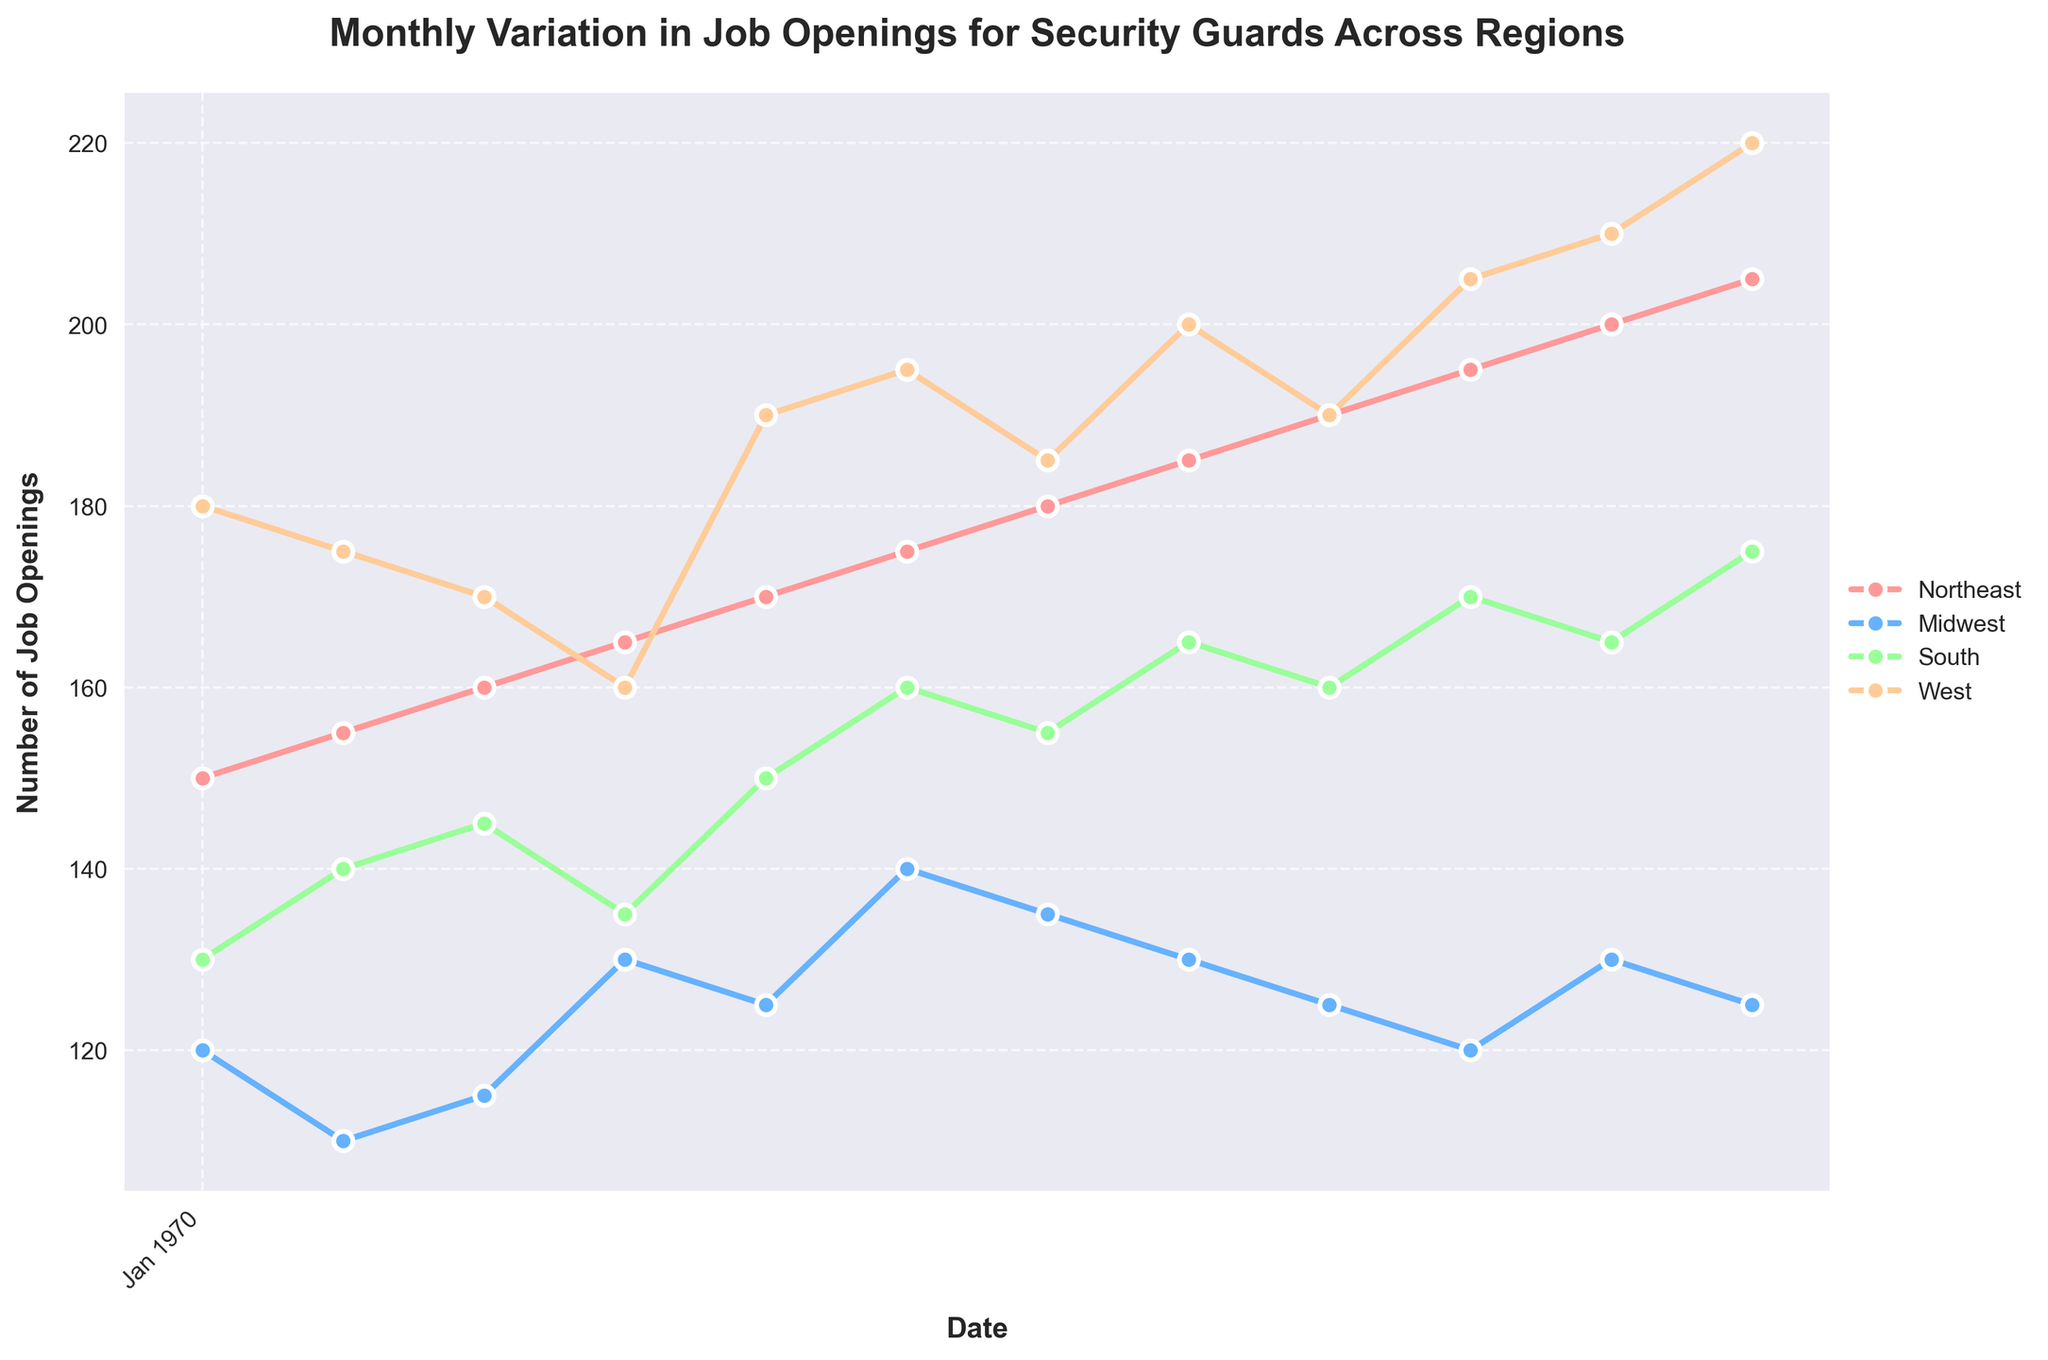What is the title of the figure? The title of the figure is usually placed at the top and is written in bold. In this case, the title is found in the center above the plot.
Answer: Monthly Variation in Job Openings for Security Guards Across Regions What are the four regions plotted in the figure? By looking at the legend usually positioned at the side or bottom of the plot, one can see the regions. In this case, they are mentioned alongside their markers and lines.
Answer: Northeast, Midwest, South, West Which region had the highest number of job openings in December 2023? To answer this, scan the December 2023 data point for each region and identify the highest value.
Answer: West How did the number of job openings in the Midwest change from January to December 2023? Examine the Midwest data points in January and December and compare them.
Answer: Dropped from 120 to 125 Which month shows the highest job openings for the South region? Follow the South region trajectory throughout the year and identify the peak point.
Answer: December In which month did the Northeast region surpass 180 job openings? Track the line representing the Northeast region and find the first month where it crosses the 180 mark.
Answer: July Compare the trends of job openings in the Northeast and Midwest from March to June 2023. View both regions’ lines from March to June and examine if they are increasing, decreasing, or remaining constant and by how much.
Answer: Northeast increased, whereas Midwest showed a slight increase What was the average number of job openings in the West region during 2023? Add all the job openings for the West region for each month and then divide by 12 to get the average.
Answer: 188.8 Which region exhibited the most consistent number of job openings throughout the year? Compare the fluctuations in the lines for all regions and identify the one with the least variation.
Answer: Midwest What is the difference in job openings between the South and the West region in June 2023? Look at the data points for both South and West regions in June 2023 and subtract the South's value from the West's.
Answer: 35 